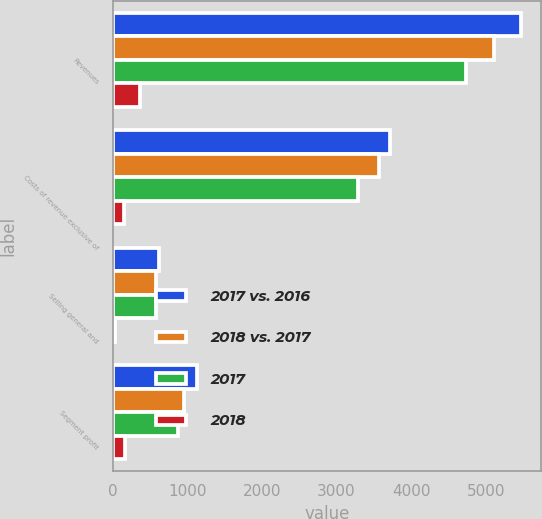<chart> <loc_0><loc_0><loc_500><loc_500><stacked_bar_chart><ecel><fcel>Revenues<fcel>Costs of revenue exclusive of<fcel>Selling general and<fcel>Segment profit<nl><fcel>2017 vs. 2016<fcel>5465<fcel>3721<fcel>616<fcel>1128<nl><fcel>2018 vs. 2017<fcel>5105<fcel>3566<fcel>582<fcel>957<nl><fcel>2017<fcel>4737<fcel>3283<fcel>579<fcel>875<nl><fcel>2018<fcel>360<fcel>155<fcel>34<fcel>171<nl></chart> 